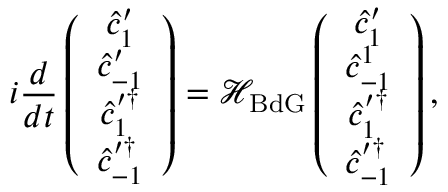<formula> <loc_0><loc_0><loc_500><loc_500>i \frac { d } { d t } \left ( \begin{array} { c } { \hat { c } _ { 1 } ^ { \prime } } \\ { \hat { c } _ { - 1 } ^ { \prime } } \\ { \hat { c } _ { 1 } ^ { \prime \dagger } } \\ { \hat { c } _ { - 1 } ^ { \prime \dagger } } \end{array} \right ) = \mathcal { H } _ { B d G } \left ( \begin{array} { c } { \hat { c } _ { 1 } ^ { \prime } } \\ { \hat { c } _ { - 1 } ^ { 1 } } \\ { \hat { c } _ { 1 } ^ { \prime \dagger } } \\ { \hat { c } _ { - 1 } ^ { \prime \dagger } } \end{array} \right ) ,</formula> 